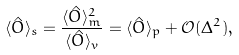Convert formula to latex. <formula><loc_0><loc_0><loc_500><loc_500>\langle \hat { O } \rangle _ { s } = \frac { \langle \hat { O } \rangle _ { m } ^ { 2 } } { \langle \hat { O } \rangle _ { v } } = \langle \hat { O } \rangle _ { p } + \mathcal { O } ( \Delta ^ { 2 } ) ,</formula> 